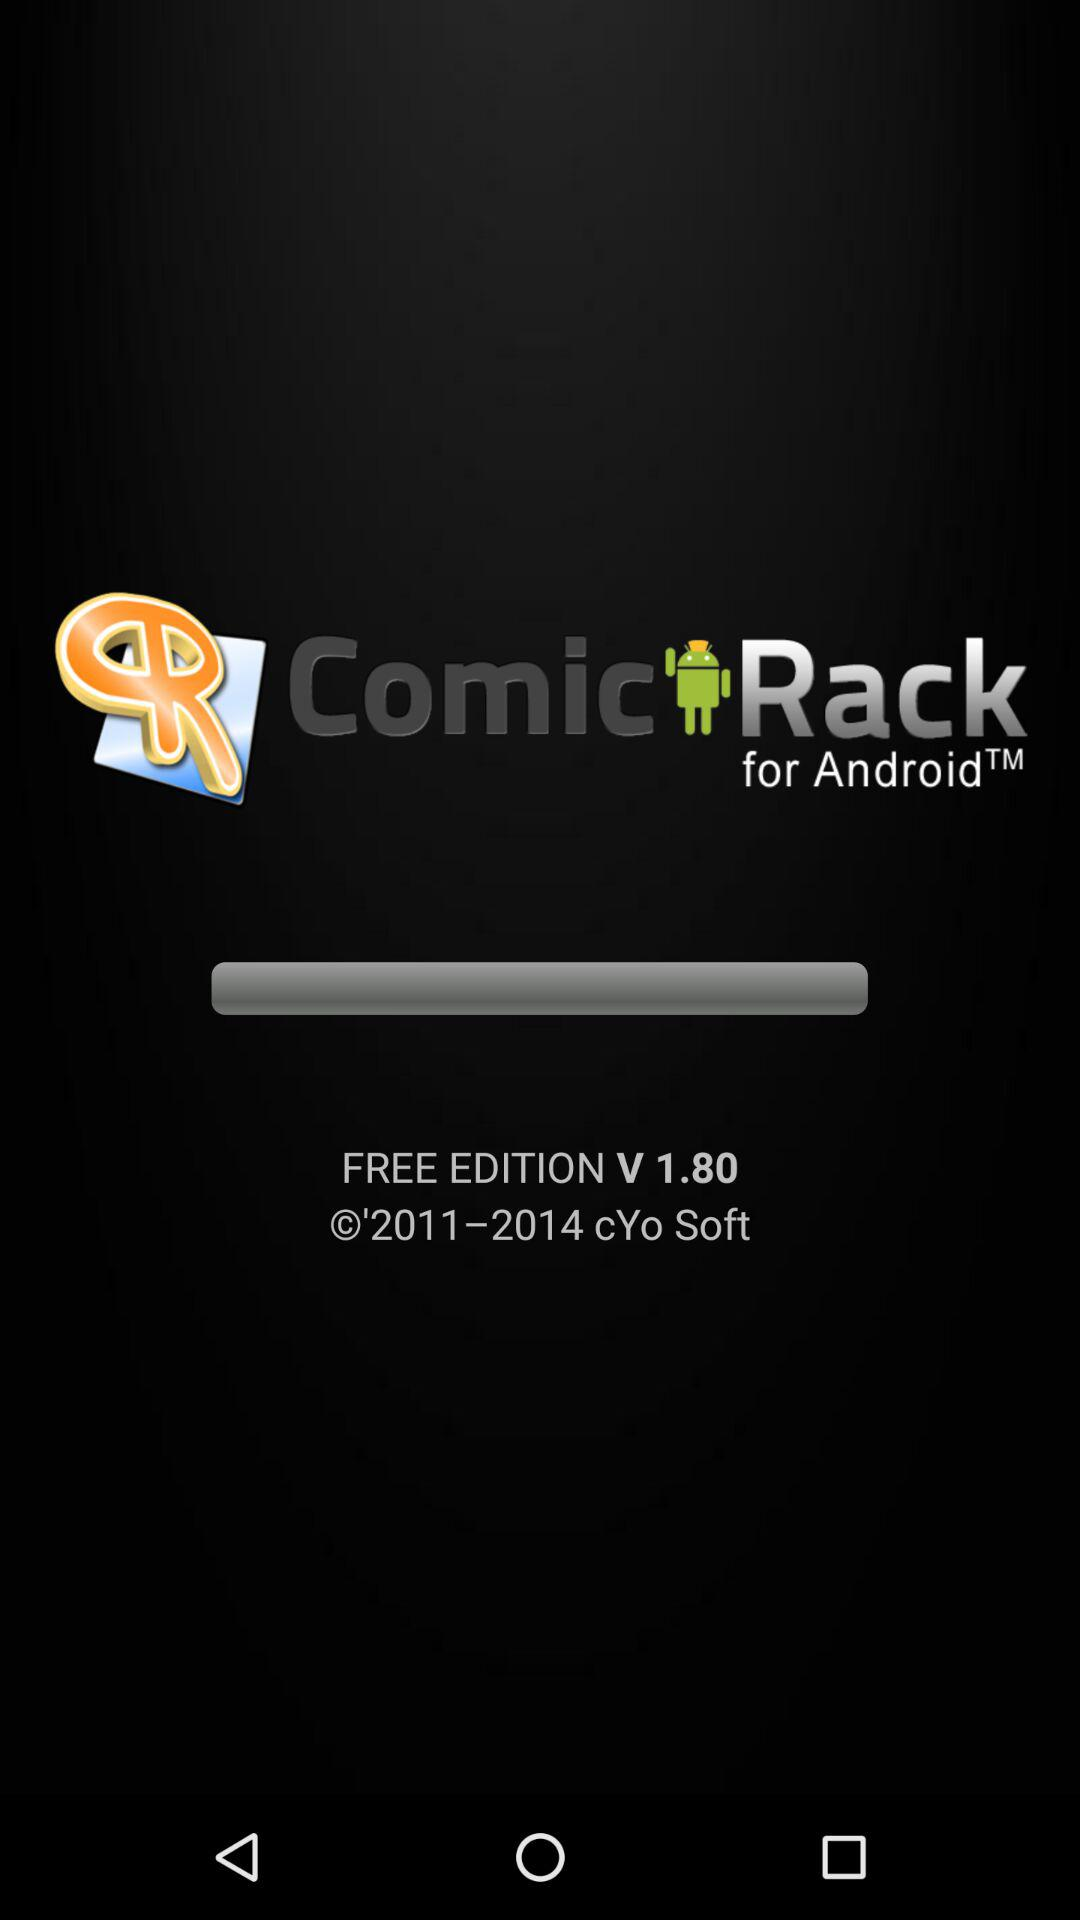What is the free version of the application that is being used? The free version of the application that is being used is V 1.80. 